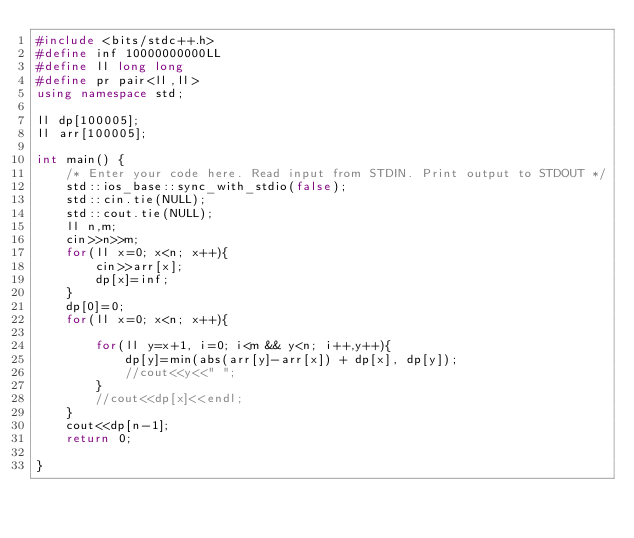Convert code to text. <code><loc_0><loc_0><loc_500><loc_500><_C++_>#include <bits/stdc++.h>
#define inf 10000000000LL
#define ll long long
#define pr pair<ll,ll>
using namespace std;

ll dp[100005];
ll arr[100005];

int main() {
    /* Enter your code here. Read input from STDIN. Print output to STDOUT */   
    std::ios_base::sync_with_stdio(false);
    std::cin.tie(NULL);
    std::cout.tie(NULL);
    ll n,m;
    cin>>n>>m;
    for(ll x=0; x<n; x++){
        cin>>arr[x];
        dp[x]=inf;
    }
    dp[0]=0;
    for(ll x=0; x<n; x++){
        
        for(ll y=x+1, i=0; i<m && y<n; i++,y++){
            dp[y]=min(abs(arr[y]-arr[x]) + dp[x], dp[y]);
            //cout<<y<<" ";
        }
        //cout<<dp[x]<<endl;
    }
    cout<<dp[n-1];
    return 0;
    
}</code> 